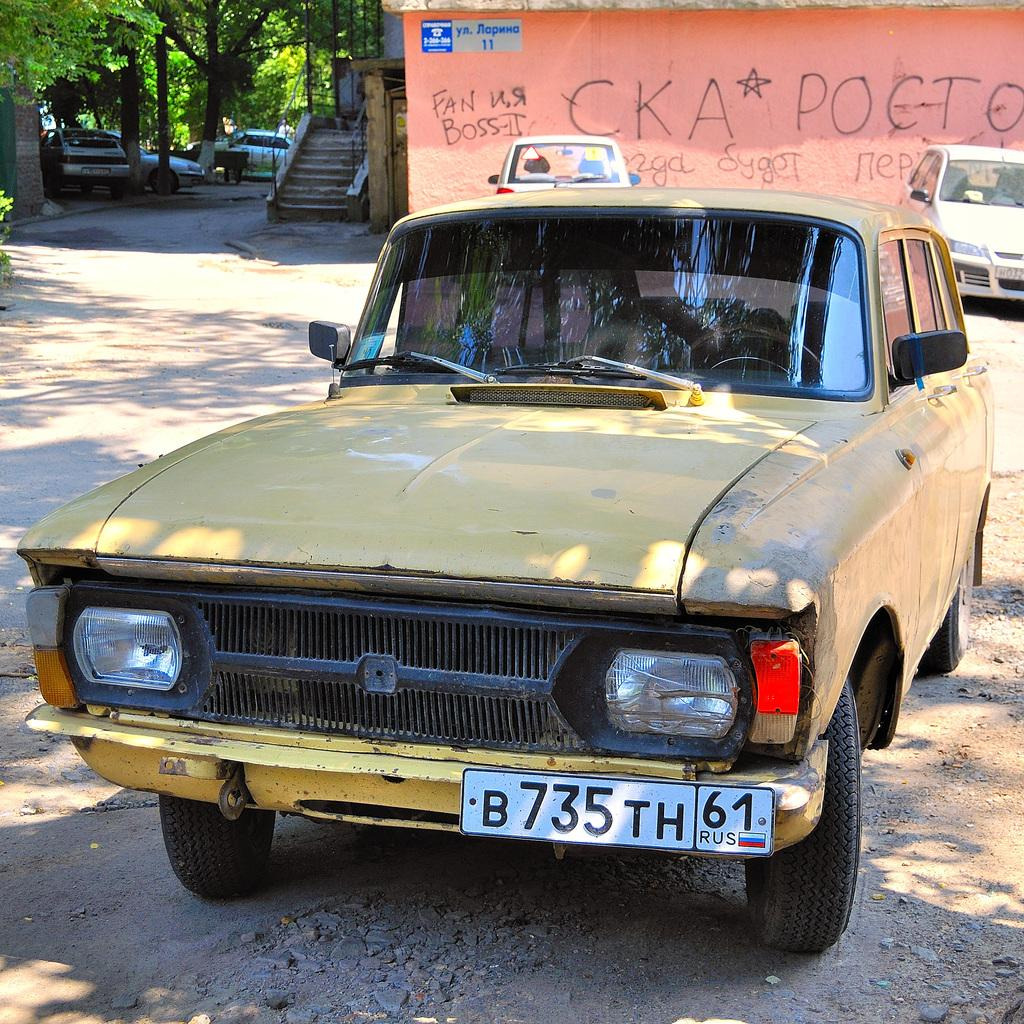<image>
Write a terse but informative summary of the picture. A yellow car in a dirt lot has a license plate that says B735TH61. 